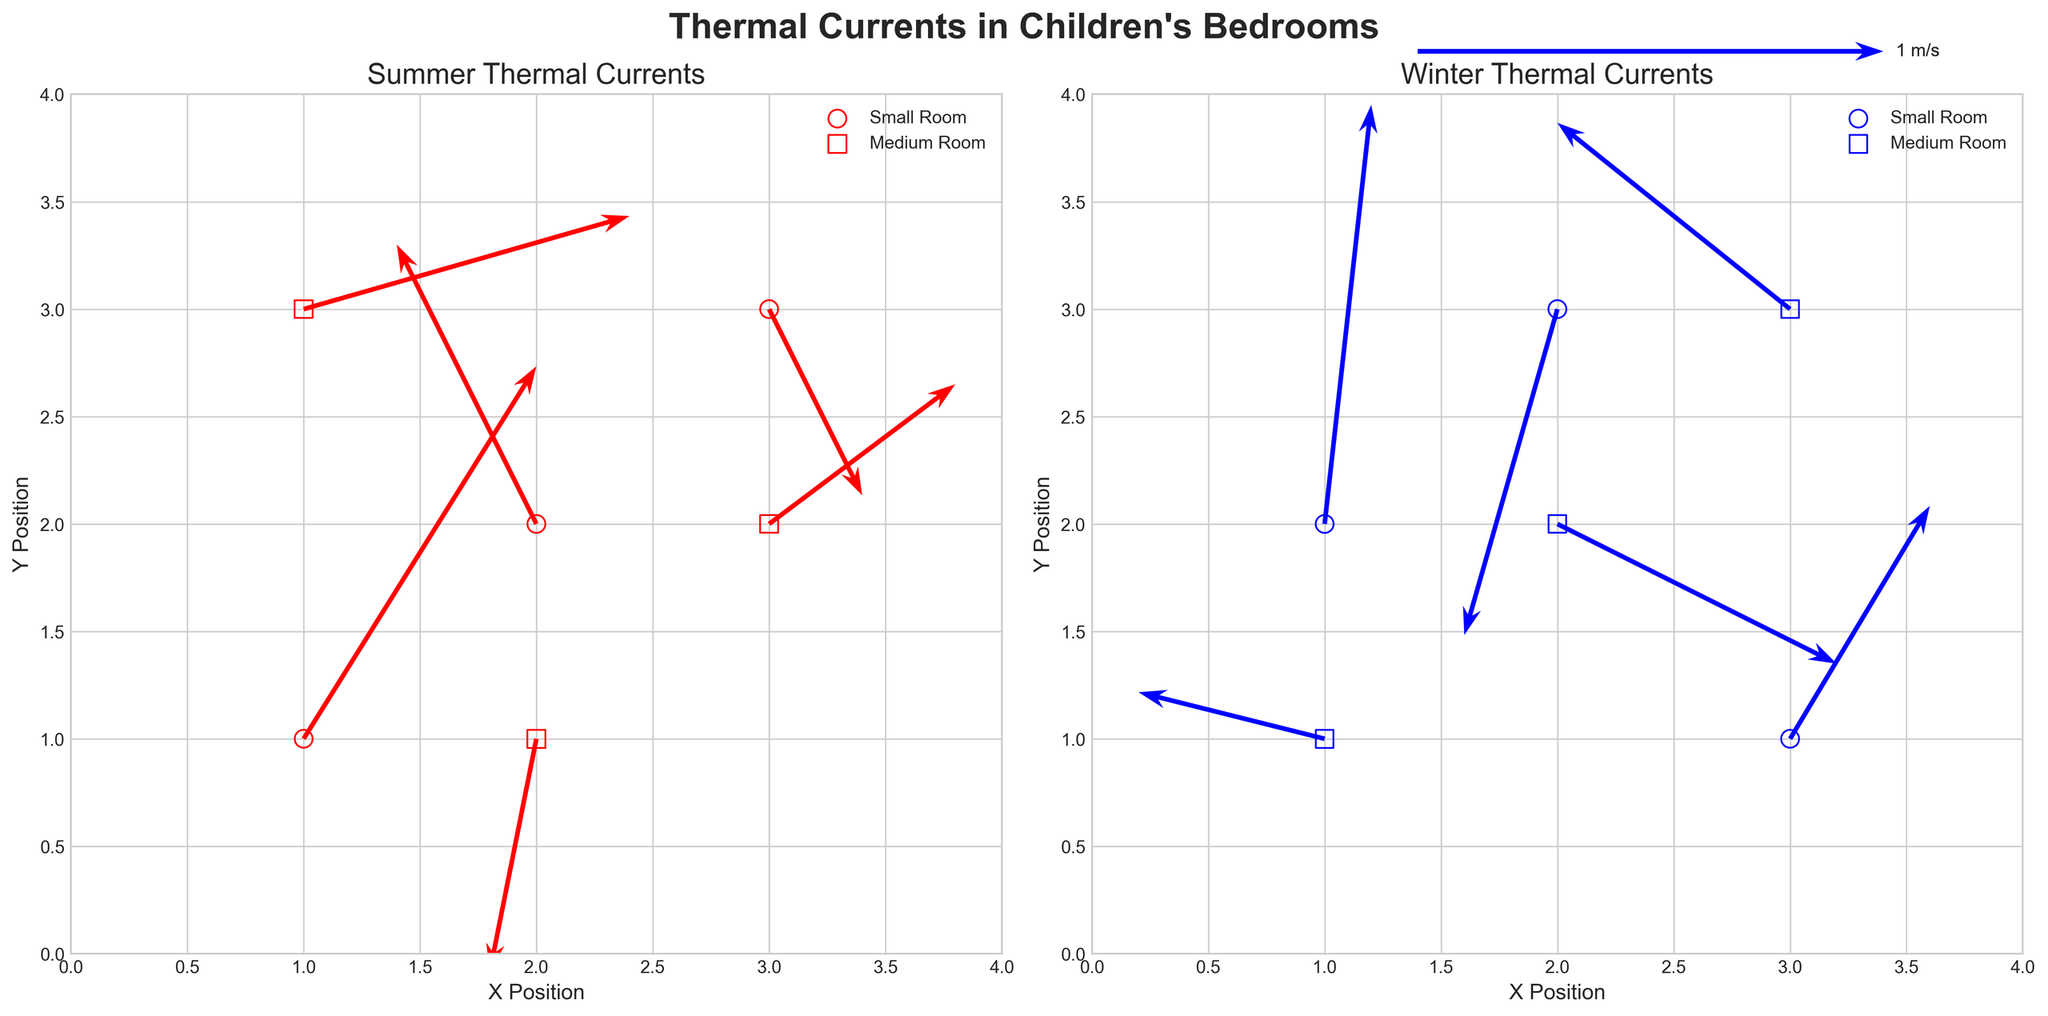How many data points are there for each season? The plots are divided into two sections, one for Summer and one for Winter. Each section has data points marked and arrows representing the thermal currents. By counting the data points in each section of the figure, we find that there are six data points for Summer and six data points for Winter.
Answer: Six data points for each season What color represents the thermal currents in Winter? Observing the colors of the arrows in both sections, we can see that the arrows are blue in the section titled "Winter Thermal Currents."
Answer: Blue Which room size shows a thermal current with the highest vertical component in Summer? By examining the vertical components of the arrows (v) in the Summer section, and comparing the length of arrows corresponding to different sizes of rooms, we see that the highest vertical component for Summer appears in the small room, with a vertical value of 0.8 at (1,1).
Answer: Small room Compare the dominant direction of thermal currents in Winter and Summer for medium-sized rooms. We analyze the direction of the arrows for medium-sized rooms in both seasons. In Winter, arrows for medium rooms have more varied directions, but a dominant southwest direction can be seen, for example, \((-0.5, 0.4)\). In Summer, the medium room currents are absent of a strong direction as there are more scattered lesser values.
Answer: Winter centers around the southwest; Summer is more scattered Which room and season show a downward thermal current trend? By looking at the orientation of the arrows pointing downward (v < 0), it's clear that both data points from Winter in a small room have downward trends, namely, \((2, 3)\) and \((3, 1)\).
Answer: Small rooms in Winter What is the average horizontal component (u) of the thermal currents in Summer? We calculate the horizontal components (u) of all arrows in the Summer section and determine the average:
\[ (0.5 + (-0.3) + 0.2 + 0.7 + (-0.1) + 0.4)/6 = 1.4/6 = 0.233 \]
Answer: 0.233 What is the general pattern of thermal current directions in small rooms during Winter? By observing the direction of the arrows in small rooms during Winter as shown in the plot, we can see a trend where the arrows predominantly point downward or have a downward component, indicating a general downward trend of thermal currents in these rooms.
Answer: Downward 